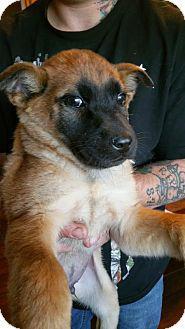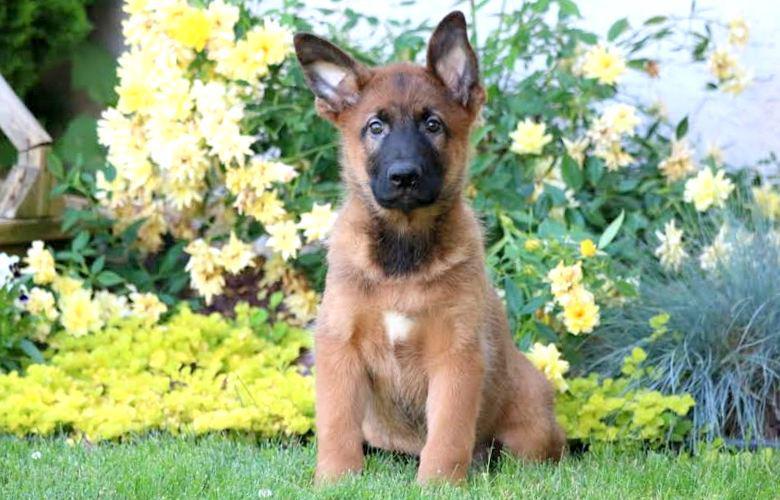The first image is the image on the left, the second image is the image on the right. Examine the images to the left and right. Is the description "One dog with a dark muzzle is reclining on the grass, and at least one dog has an opened, non-snarling mouth." accurate? Answer yes or no. No. The first image is the image on the left, the second image is the image on the right. Evaluate the accuracy of this statement regarding the images: "There is a human touching one of the dogs.". Is it true? Answer yes or no. Yes. 